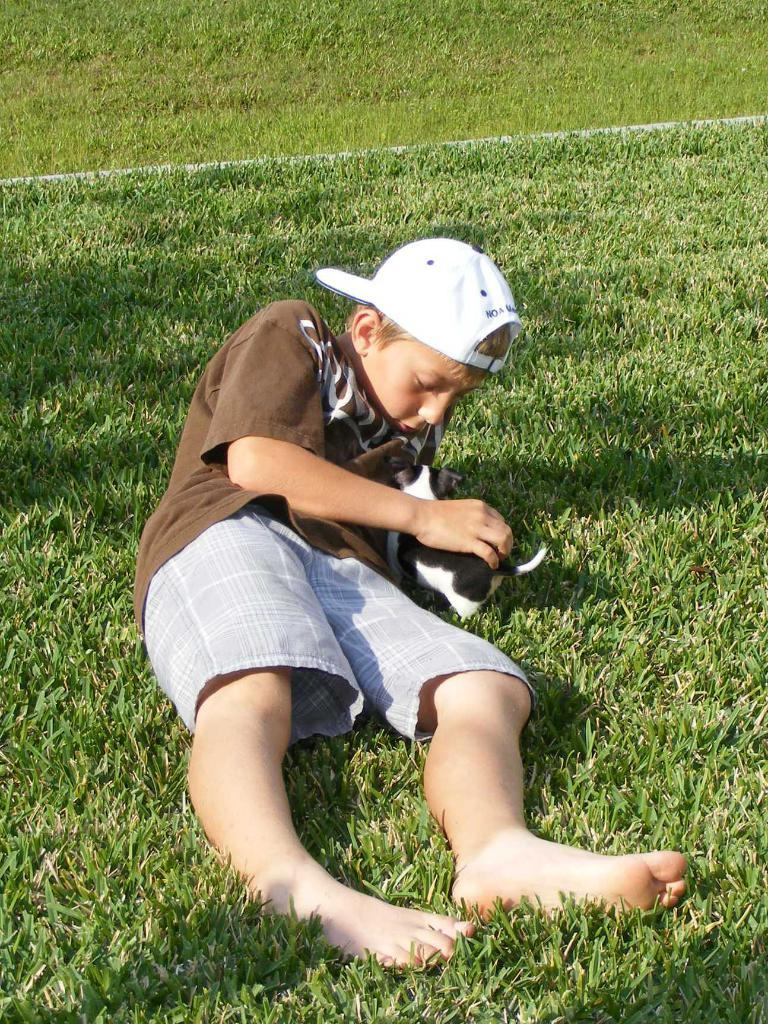Who is the main subject in the image? There is a boy in the image. What is the boy doing in the image? The boy is lying on the grass. What is the boy wearing in the image? The boy is wearing a brown t-shirt and a hat. What is the boy holding in the image? The boy is holding an animal. What type of magic is the boy performing in the image? There is no indication of magic in the image; the boy is simply lying on the grass and holding an animal. What kind of cap is the boy wearing in the image? The boy is wearing a hat, but the specific type of hat (e.g., baseball cap, fedora) cannot be determined from the image. 